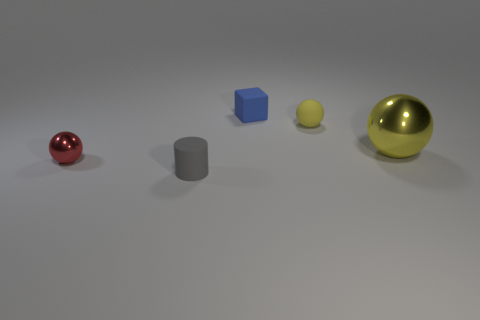Add 2 tiny yellow rubber objects. How many objects exist? 7 Subtract all cubes. How many objects are left? 4 Add 3 yellow balls. How many yellow balls exist? 5 Subtract 0 red cylinders. How many objects are left? 5 Subtract all green metal cylinders. Subtract all tiny gray matte cylinders. How many objects are left? 4 Add 4 yellow matte things. How many yellow matte things are left? 5 